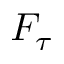Convert formula to latex. <formula><loc_0><loc_0><loc_500><loc_500>F _ { \tau }</formula> 